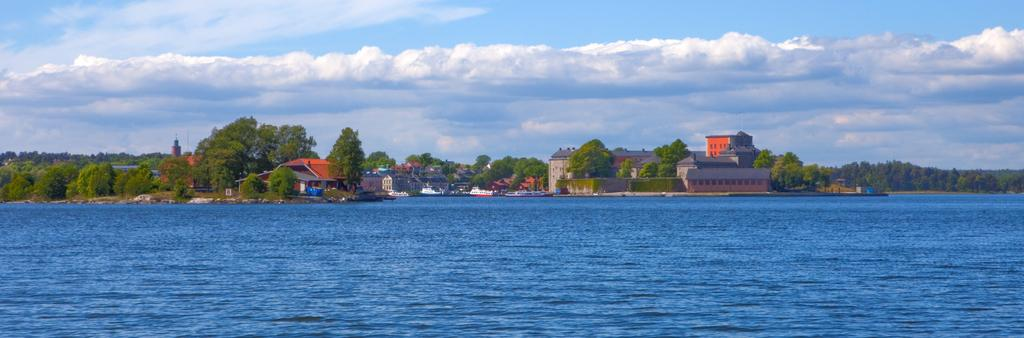What is located at the bottom of the image? There is a sea at the bottom of the image. What can be seen in the middle of the image? There are buildings and trees in the middle of the image. What is visible at the top of the image? The sky is visible at the top of the image, and what is the condition of the sky? What type of texture can be seen on the edge of the sea in the image? There is no specific texture mentioned on the edge of the sea in the image, and the image does not provide enough detail to determine the texture. Who is the writer of the buildings in the image? There is no writer associated with the buildings in the image; they are architectural structures. 